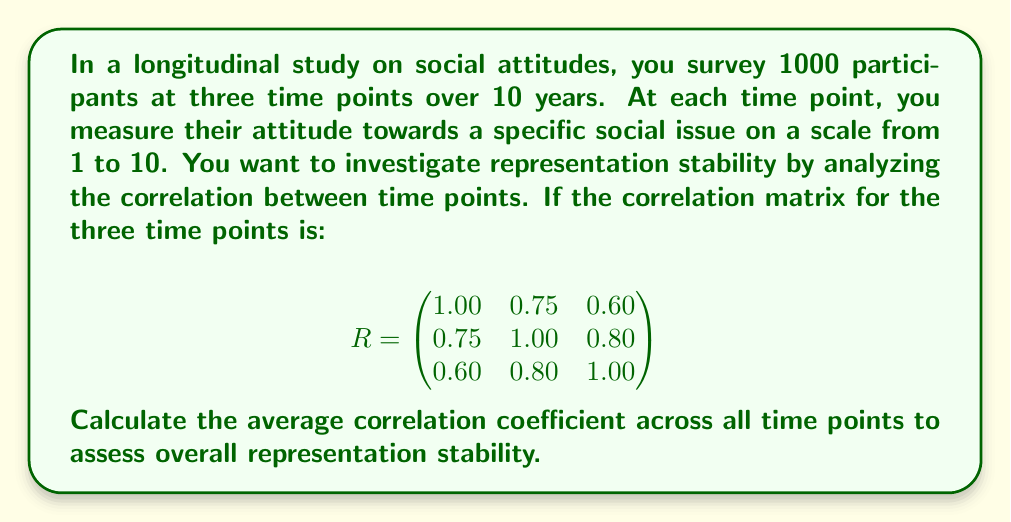Can you answer this question? To calculate the average correlation coefficient across all time points:

1. Identify the unique correlation coefficients:
   $r_{12} = 0.75$
   $r_{13} = 0.60$
   $r_{23} = 0.80$

2. Sum these coefficients:
   $\sum r = 0.75 + 0.60 + 0.80 = 2.15$

3. Count the number of unique coefficients:
   $n = 3$

4. Calculate the average correlation coefficient:
   $$\bar{r} = \frac{\sum r}{n} = \frac{2.15}{3} = 0.7167$$

5. Round to three decimal places:
   $\bar{r} \approx 0.717$

This average correlation coefficient represents the overall representation stability across the three time points in the longitudinal study.
Answer: 0.717 